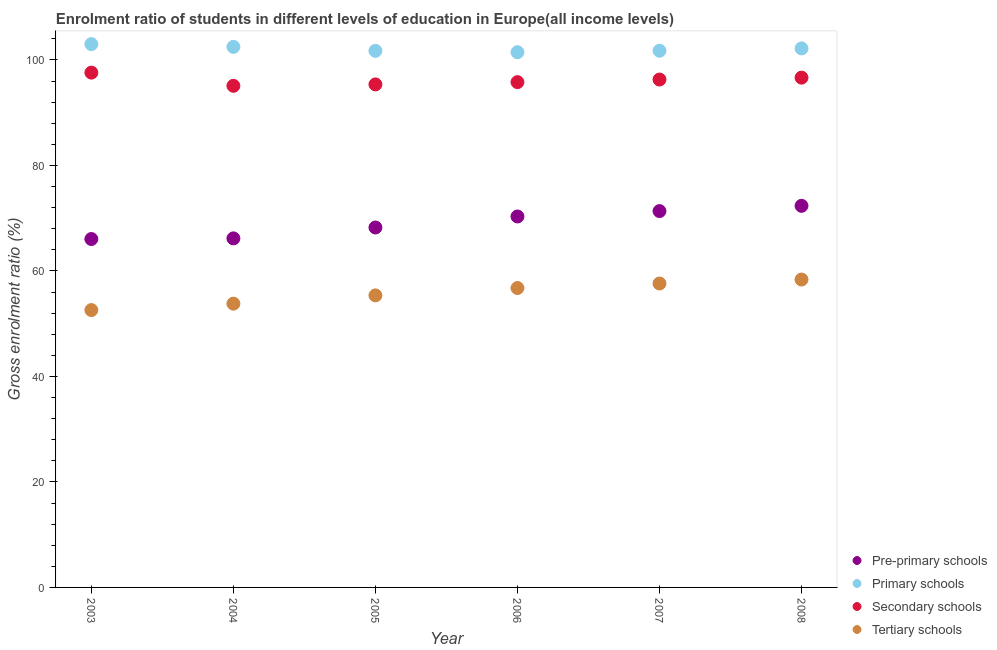What is the gross enrolment ratio in pre-primary schools in 2004?
Offer a very short reply. 66.17. Across all years, what is the maximum gross enrolment ratio in tertiary schools?
Provide a short and direct response. 58.37. Across all years, what is the minimum gross enrolment ratio in tertiary schools?
Ensure brevity in your answer.  52.58. What is the total gross enrolment ratio in tertiary schools in the graph?
Keep it short and to the point. 334.49. What is the difference between the gross enrolment ratio in primary schools in 2005 and that in 2007?
Make the answer very short. -0.02. What is the difference between the gross enrolment ratio in primary schools in 2006 and the gross enrolment ratio in tertiary schools in 2004?
Your response must be concise. 47.67. What is the average gross enrolment ratio in secondary schools per year?
Your response must be concise. 96.13. In the year 2007, what is the difference between the gross enrolment ratio in primary schools and gross enrolment ratio in tertiary schools?
Keep it short and to the point. 44.13. What is the ratio of the gross enrolment ratio in secondary schools in 2003 to that in 2007?
Keep it short and to the point. 1.01. What is the difference between the highest and the second highest gross enrolment ratio in secondary schools?
Keep it short and to the point. 0.95. What is the difference between the highest and the lowest gross enrolment ratio in primary schools?
Your answer should be very brief. 1.53. In how many years, is the gross enrolment ratio in primary schools greater than the average gross enrolment ratio in primary schools taken over all years?
Offer a terse response. 3. Is it the case that in every year, the sum of the gross enrolment ratio in primary schools and gross enrolment ratio in pre-primary schools is greater than the sum of gross enrolment ratio in secondary schools and gross enrolment ratio in tertiary schools?
Ensure brevity in your answer.  No. Is it the case that in every year, the sum of the gross enrolment ratio in pre-primary schools and gross enrolment ratio in primary schools is greater than the gross enrolment ratio in secondary schools?
Keep it short and to the point. Yes. Does the gross enrolment ratio in secondary schools monotonically increase over the years?
Your answer should be very brief. No. Is the gross enrolment ratio in tertiary schools strictly less than the gross enrolment ratio in pre-primary schools over the years?
Make the answer very short. Yes. How many dotlines are there?
Your response must be concise. 4. What is the difference between two consecutive major ticks on the Y-axis?
Offer a terse response. 20. Are the values on the major ticks of Y-axis written in scientific E-notation?
Ensure brevity in your answer.  No. Where does the legend appear in the graph?
Provide a succinct answer. Bottom right. How many legend labels are there?
Your response must be concise. 4. What is the title of the graph?
Keep it short and to the point. Enrolment ratio of students in different levels of education in Europe(all income levels). Does "Periodicity assessment" appear as one of the legend labels in the graph?
Keep it short and to the point. No. What is the label or title of the X-axis?
Offer a very short reply. Year. What is the Gross enrolment ratio (%) in Pre-primary schools in 2003?
Your response must be concise. 66.05. What is the Gross enrolment ratio (%) in Primary schools in 2003?
Provide a succinct answer. 103. What is the Gross enrolment ratio (%) of Secondary schools in 2003?
Offer a terse response. 97.59. What is the Gross enrolment ratio (%) in Tertiary schools in 2003?
Provide a short and direct response. 52.58. What is the Gross enrolment ratio (%) in Pre-primary schools in 2004?
Offer a very short reply. 66.17. What is the Gross enrolment ratio (%) in Primary schools in 2004?
Provide a succinct answer. 102.48. What is the Gross enrolment ratio (%) of Secondary schools in 2004?
Your response must be concise. 95.09. What is the Gross enrolment ratio (%) in Tertiary schools in 2004?
Keep it short and to the point. 53.8. What is the Gross enrolment ratio (%) in Pre-primary schools in 2005?
Make the answer very short. 68.23. What is the Gross enrolment ratio (%) of Primary schools in 2005?
Your answer should be very brief. 101.73. What is the Gross enrolment ratio (%) of Secondary schools in 2005?
Make the answer very short. 95.36. What is the Gross enrolment ratio (%) of Tertiary schools in 2005?
Make the answer very short. 55.37. What is the Gross enrolment ratio (%) of Pre-primary schools in 2006?
Provide a short and direct response. 70.32. What is the Gross enrolment ratio (%) of Primary schools in 2006?
Offer a terse response. 101.46. What is the Gross enrolment ratio (%) of Secondary schools in 2006?
Provide a short and direct response. 95.79. What is the Gross enrolment ratio (%) of Tertiary schools in 2006?
Your response must be concise. 56.76. What is the Gross enrolment ratio (%) in Pre-primary schools in 2007?
Ensure brevity in your answer.  71.35. What is the Gross enrolment ratio (%) in Primary schools in 2007?
Provide a succinct answer. 101.74. What is the Gross enrolment ratio (%) in Secondary schools in 2007?
Offer a terse response. 96.29. What is the Gross enrolment ratio (%) of Tertiary schools in 2007?
Keep it short and to the point. 57.62. What is the Gross enrolment ratio (%) of Pre-primary schools in 2008?
Keep it short and to the point. 72.34. What is the Gross enrolment ratio (%) of Primary schools in 2008?
Keep it short and to the point. 102.19. What is the Gross enrolment ratio (%) of Secondary schools in 2008?
Ensure brevity in your answer.  96.64. What is the Gross enrolment ratio (%) of Tertiary schools in 2008?
Provide a short and direct response. 58.37. Across all years, what is the maximum Gross enrolment ratio (%) in Pre-primary schools?
Offer a very short reply. 72.34. Across all years, what is the maximum Gross enrolment ratio (%) in Primary schools?
Ensure brevity in your answer.  103. Across all years, what is the maximum Gross enrolment ratio (%) of Secondary schools?
Ensure brevity in your answer.  97.59. Across all years, what is the maximum Gross enrolment ratio (%) in Tertiary schools?
Give a very brief answer. 58.37. Across all years, what is the minimum Gross enrolment ratio (%) in Pre-primary schools?
Offer a very short reply. 66.05. Across all years, what is the minimum Gross enrolment ratio (%) in Primary schools?
Your answer should be compact. 101.46. Across all years, what is the minimum Gross enrolment ratio (%) of Secondary schools?
Make the answer very short. 95.09. Across all years, what is the minimum Gross enrolment ratio (%) of Tertiary schools?
Keep it short and to the point. 52.58. What is the total Gross enrolment ratio (%) in Pre-primary schools in the graph?
Your response must be concise. 414.47. What is the total Gross enrolment ratio (%) of Primary schools in the graph?
Offer a terse response. 612.6. What is the total Gross enrolment ratio (%) in Secondary schools in the graph?
Your answer should be very brief. 576.77. What is the total Gross enrolment ratio (%) in Tertiary schools in the graph?
Ensure brevity in your answer.  334.49. What is the difference between the Gross enrolment ratio (%) in Pre-primary schools in 2003 and that in 2004?
Give a very brief answer. -0.12. What is the difference between the Gross enrolment ratio (%) in Primary schools in 2003 and that in 2004?
Give a very brief answer. 0.52. What is the difference between the Gross enrolment ratio (%) in Secondary schools in 2003 and that in 2004?
Offer a very short reply. 2.5. What is the difference between the Gross enrolment ratio (%) of Tertiary schools in 2003 and that in 2004?
Offer a very short reply. -1.21. What is the difference between the Gross enrolment ratio (%) of Pre-primary schools in 2003 and that in 2005?
Give a very brief answer. -2.19. What is the difference between the Gross enrolment ratio (%) in Primary schools in 2003 and that in 2005?
Your answer should be very brief. 1.27. What is the difference between the Gross enrolment ratio (%) of Secondary schools in 2003 and that in 2005?
Ensure brevity in your answer.  2.23. What is the difference between the Gross enrolment ratio (%) of Tertiary schools in 2003 and that in 2005?
Your response must be concise. -2.79. What is the difference between the Gross enrolment ratio (%) of Pre-primary schools in 2003 and that in 2006?
Your response must be concise. -4.28. What is the difference between the Gross enrolment ratio (%) in Primary schools in 2003 and that in 2006?
Give a very brief answer. 1.53. What is the difference between the Gross enrolment ratio (%) of Secondary schools in 2003 and that in 2006?
Keep it short and to the point. 1.8. What is the difference between the Gross enrolment ratio (%) of Tertiary schools in 2003 and that in 2006?
Provide a short and direct response. -4.18. What is the difference between the Gross enrolment ratio (%) in Pre-primary schools in 2003 and that in 2007?
Make the answer very short. -5.3. What is the difference between the Gross enrolment ratio (%) of Primary schools in 2003 and that in 2007?
Keep it short and to the point. 1.25. What is the difference between the Gross enrolment ratio (%) of Secondary schools in 2003 and that in 2007?
Offer a very short reply. 1.31. What is the difference between the Gross enrolment ratio (%) of Tertiary schools in 2003 and that in 2007?
Offer a very short reply. -5.04. What is the difference between the Gross enrolment ratio (%) of Pre-primary schools in 2003 and that in 2008?
Offer a terse response. -6.29. What is the difference between the Gross enrolment ratio (%) of Primary schools in 2003 and that in 2008?
Make the answer very short. 0.81. What is the difference between the Gross enrolment ratio (%) of Secondary schools in 2003 and that in 2008?
Ensure brevity in your answer.  0.95. What is the difference between the Gross enrolment ratio (%) of Tertiary schools in 2003 and that in 2008?
Offer a terse response. -5.79. What is the difference between the Gross enrolment ratio (%) of Pre-primary schools in 2004 and that in 2005?
Offer a very short reply. -2.06. What is the difference between the Gross enrolment ratio (%) in Primary schools in 2004 and that in 2005?
Provide a short and direct response. 0.75. What is the difference between the Gross enrolment ratio (%) in Secondary schools in 2004 and that in 2005?
Your answer should be very brief. -0.27. What is the difference between the Gross enrolment ratio (%) of Tertiary schools in 2004 and that in 2005?
Your response must be concise. -1.57. What is the difference between the Gross enrolment ratio (%) of Pre-primary schools in 2004 and that in 2006?
Provide a short and direct response. -4.15. What is the difference between the Gross enrolment ratio (%) of Primary schools in 2004 and that in 2006?
Make the answer very short. 1.01. What is the difference between the Gross enrolment ratio (%) of Secondary schools in 2004 and that in 2006?
Your answer should be very brief. -0.7. What is the difference between the Gross enrolment ratio (%) of Tertiary schools in 2004 and that in 2006?
Your answer should be compact. -2.97. What is the difference between the Gross enrolment ratio (%) in Pre-primary schools in 2004 and that in 2007?
Your response must be concise. -5.17. What is the difference between the Gross enrolment ratio (%) of Primary schools in 2004 and that in 2007?
Your response must be concise. 0.73. What is the difference between the Gross enrolment ratio (%) in Secondary schools in 2004 and that in 2007?
Give a very brief answer. -1.19. What is the difference between the Gross enrolment ratio (%) in Tertiary schools in 2004 and that in 2007?
Ensure brevity in your answer.  -3.82. What is the difference between the Gross enrolment ratio (%) in Pre-primary schools in 2004 and that in 2008?
Keep it short and to the point. -6.17. What is the difference between the Gross enrolment ratio (%) in Primary schools in 2004 and that in 2008?
Your answer should be very brief. 0.29. What is the difference between the Gross enrolment ratio (%) of Secondary schools in 2004 and that in 2008?
Your response must be concise. -1.55. What is the difference between the Gross enrolment ratio (%) of Tertiary schools in 2004 and that in 2008?
Provide a short and direct response. -4.57. What is the difference between the Gross enrolment ratio (%) of Pre-primary schools in 2005 and that in 2006?
Your response must be concise. -2.09. What is the difference between the Gross enrolment ratio (%) in Primary schools in 2005 and that in 2006?
Your answer should be very brief. 0.26. What is the difference between the Gross enrolment ratio (%) of Secondary schools in 2005 and that in 2006?
Make the answer very short. -0.43. What is the difference between the Gross enrolment ratio (%) in Tertiary schools in 2005 and that in 2006?
Your answer should be compact. -1.4. What is the difference between the Gross enrolment ratio (%) in Pre-primary schools in 2005 and that in 2007?
Keep it short and to the point. -3.11. What is the difference between the Gross enrolment ratio (%) in Primary schools in 2005 and that in 2007?
Your answer should be very brief. -0.02. What is the difference between the Gross enrolment ratio (%) in Secondary schools in 2005 and that in 2007?
Give a very brief answer. -0.92. What is the difference between the Gross enrolment ratio (%) of Tertiary schools in 2005 and that in 2007?
Offer a very short reply. -2.25. What is the difference between the Gross enrolment ratio (%) in Pre-primary schools in 2005 and that in 2008?
Your response must be concise. -4.11. What is the difference between the Gross enrolment ratio (%) of Primary schools in 2005 and that in 2008?
Keep it short and to the point. -0.46. What is the difference between the Gross enrolment ratio (%) in Secondary schools in 2005 and that in 2008?
Offer a very short reply. -1.28. What is the difference between the Gross enrolment ratio (%) of Tertiary schools in 2005 and that in 2008?
Provide a succinct answer. -3. What is the difference between the Gross enrolment ratio (%) of Pre-primary schools in 2006 and that in 2007?
Your response must be concise. -1.02. What is the difference between the Gross enrolment ratio (%) of Primary schools in 2006 and that in 2007?
Your answer should be very brief. -0.28. What is the difference between the Gross enrolment ratio (%) in Secondary schools in 2006 and that in 2007?
Keep it short and to the point. -0.49. What is the difference between the Gross enrolment ratio (%) of Tertiary schools in 2006 and that in 2007?
Give a very brief answer. -0.86. What is the difference between the Gross enrolment ratio (%) of Pre-primary schools in 2006 and that in 2008?
Make the answer very short. -2.02. What is the difference between the Gross enrolment ratio (%) in Primary schools in 2006 and that in 2008?
Ensure brevity in your answer.  -0.73. What is the difference between the Gross enrolment ratio (%) of Secondary schools in 2006 and that in 2008?
Ensure brevity in your answer.  -0.85. What is the difference between the Gross enrolment ratio (%) of Tertiary schools in 2006 and that in 2008?
Offer a terse response. -1.61. What is the difference between the Gross enrolment ratio (%) of Pre-primary schools in 2007 and that in 2008?
Make the answer very short. -1. What is the difference between the Gross enrolment ratio (%) of Primary schools in 2007 and that in 2008?
Keep it short and to the point. -0.45. What is the difference between the Gross enrolment ratio (%) of Secondary schools in 2007 and that in 2008?
Make the answer very short. -0.36. What is the difference between the Gross enrolment ratio (%) of Tertiary schools in 2007 and that in 2008?
Keep it short and to the point. -0.75. What is the difference between the Gross enrolment ratio (%) of Pre-primary schools in 2003 and the Gross enrolment ratio (%) of Primary schools in 2004?
Your answer should be very brief. -36.43. What is the difference between the Gross enrolment ratio (%) in Pre-primary schools in 2003 and the Gross enrolment ratio (%) in Secondary schools in 2004?
Your response must be concise. -29.05. What is the difference between the Gross enrolment ratio (%) of Pre-primary schools in 2003 and the Gross enrolment ratio (%) of Tertiary schools in 2004?
Offer a terse response. 12.25. What is the difference between the Gross enrolment ratio (%) in Primary schools in 2003 and the Gross enrolment ratio (%) in Secondary schools in 2004?
Your response must be concise. 7.9. What is the difference between the Gross enrolment ratio (%) in Primary schools in 2003 and the Gross enrolment ratio (%) in Tertiary schools in 2004?
Give a very brief answer. 49.2. What is the difference between the Gross enrolment ratio (%) of Secondary schools in 2003 and the Gross enrolment ratio (%) of Tertiary schools in 2004?
Keep it short and to the point. 43.8. What is the difference between the Gross enrolment ratio (%) of Pre-primary schools in 2003 and the Gross enrolment ratio (%) of Primary schools in 2005?
Your answer should be very brief. -35.68. What is the difference between the Gross enrolment ratio (%) of Pre-primary schools in 2003 and the Gross enrolment ratio (%) of Secondary schools in 2005?
Your answer should be compact. -29.31. What is the difference between the Gross enrolment ratio (%) of Pre-primary schools in 2003 and the Gross enrolment ratio (%) of Tertiary schools in 2005?
Your response must be concise. 10.68. What is the difference between the Gross enrolment ratio (%) in Primary schools in 2003 and the Gross enrolment ratio (%) in Secondary schools in 2005?
Keep it short and to the point. 7.64. What is the difference between the Gross enrolment ratio (%) of Primary schools in 2003 and the Gross enrolment ratio (%) of Tertiary schools in 2005?
Ensure brevity in your answer.  47.63. What is the difference between the Gross enrolment ratio (%) in Secondary schools in 2003 and the Gross enrolment ratio (%) in Tertiary schools in 2005?
Make the answer very short. 42.23. What is the difference between the Gross enrolment ratio (%) in Pre-primary schools in 2003 and the Gross enrolment ratio (%) in Primary schools in 2006?
Keep it short and to the point. -35.42. What is the difference between the Gross enrolment ratio (%) in Pre-primary schools in 2003 and the Gross enrolment ratio (%) in Secondary schools in 2006?
Your response must be concise. -29.75. What is the difference between the Gross enrolment ratio (%) in Pre-primary schools in 2003 and the Gross enrolment ratio (%) in Tertiary schools in 2006?
Your answer should be very brief. 9.29. What is the difference between the Gross enrolment ratio (%) in Primary schools in 2003 and the Gross enrolment ratio (%) in Secondary schools in 2006?
Make the answer very short. 7.21. What is the difference between the Gross enrolment ratio (%) in Primary schools in 2003 and the Gross enrolment ratio (%) in Tertiary schools in 2006?
Your answer should be compact. 46.24. What is the difference between the Gross enrolment ratio (%) in Secondary schools in 2003 and the Gross enrolment ratio (%) in Tertiary schools in 2006?
Ensure brevity in your answer.  40.83. What is the difference between the Gross enrolment ratio (%) in Pre-primary schools in 2003 and the Gross enrolment ratio (%) in Primary schools in 2007?
Your response must be concise. -35.7. What is the difference between the Gross enrolment ratio (%) of Pre-primary schools in 2003 and the Gross enrolment ratio (%) of Secondary schools in 2007?
Provide a short and direct response. -30.24. What is the difference between the Gross enrolment ratio (%) of Pre-primary schools in 2003 and the Gross enrolment ratio (%) of Tertiary schools in 2007?
Provide a short and direct response. 8.43. What is the difference between the Gross enrolment ratio (%) in Primary schools in 2003 and the Gross enrolment ratio (%) in Secondary schools in 2007?
Give a very brief answer. 6.71. What is the difference between the Gross enrolment ratio (%) of Primary schools in 2003 and the Gross enrolment ratio (%) of Tertiary schools in 2007?
Keep it short and to the point. 45.38. What is the difference between the Gross enrolment ratio (%) in Secondary schools in 2003 and the Gross enrolment ratio (%) in Tertiary schools in 2007?
Your response must be concise. 39.98. What is the difference between the Gross enrolment ratio (%) in Pre-primary schools in 2003 and the Gross enrolment ratio (%) in Primary schools in 2008?
Your answer should be compact. -36.14. What is the difference between the Gross enrolment ratio (%) in Pre-primary schools in 2003 and the Gross enrolment ratio (%) in Secondary schools in 2008?
Your answer should be compact. -30.6. What is the difference between the Gross enrolment ratio (%) in Pre-primary schools in 2003 and the Gross enrolment ratio (%) in Tertiary schools in 2008?
Offer a terse response. 7.68. What is the difference between the Gross enrolment ratio (%) of Primary schools in 2003 and the Gross enrolment ratio (%) of Secondary schools in 2008?
Keep it short and to the point. 6.35. What is the difference between the Gross enrolment ratio (%) in Primary schools in 2003 and the Gross enrolment ratio (%) in Tertiary schools in 2008?
Give a very brief answer. 44.63. What is the difference between the Gross enrolment ratio (%) in Secondary schools in 2003 and the Gross enrolment ratio (%) in Tertiary schools in 2008?
Keep it short and to the point. 39.23. What is the difference between the Gross enrolment ratio (%) of Pre-primary schools in 2004 and the Gross enrolment ratio (%) of Primary schools in 2005?
Keep it short and to the point. -35.55. What is the difference between the Gross enrolment ratio (%) of Pre-primary schools in 2004 and the Gross enrolment ratio (%) of Secondary schools in 2005?
Make the answer very short. -29.19. What is the difference between the Gross enrolment ratio (%) in Pre-primary schools in 2004 and the Gross enrolment ratio (%) in Tertiary schools in 2005?
Make the answer very short. 10.81. What is the difference between the Gross enrolment ratio (%) in Primary schools in 2004 and the Gross enrolment ratio (%) in Secondary schools in 2005?
Ensure brevity in your answer.  7.11. What is the difference between the Gross enrolment ratio (%) in Primary schools in 2004 and the Gross enrolment ratio (%) in Tertiary schools in 2005?
Keep it short and to the point. 47.11. What is the difference between the Gross enrolment ratio (%) of Secondary schools in 2004 and the Gross enrolment ratio (%) of Tertiary schools in 2005?
Your answer should be very brief. 39.73. What is the difference between the Gross enrolment ratio (%) of Pre-primary schools in 2004 and the Gross enrolment ratio (%) of Primary schools in 2006?
Offer a very short reply. -35.29. What is the difference between the Gross enrolment ratio (%) of Pre-primary schools in 2004 and the Gross enrolment ratio (%) of Secondary schools in 2006?
Your answer should be compact. -29.62. What is the difference between the Gross enrolment ratio (%) in Pre-primary schools in 2004 and the Gross enrolment ratio (%) in Tertiary schools in 2006?
Provide a succinct answer. 9.41. What is the difference between the Gross enrolment ratio (%) in Primary schools in 2004 and the Gross enrolment ratio (%) in Secondary schools in 2006?
Offer a terse response. 6.68. What is the difference between the Gross enrolment ratio (%) in Primary schools in 2004 and the Gross enrolment ratio (%) in Tertiary schools in 2006?
Your response must be concise. 45.72. What is the difference between the Gross enrolment ratio (%) in Secondary schools in 2004 and the Gross enrolment ratio (%) in Tertiary schools in 2006?
Offer a very short reply. 38.33. What is the difference between the Gross enrolment ratio (%) of Pre-primary schools in 2004 and the Gross enrolment ratio (%) of Primary schools in 2007?
Offer a very short reply. -35.57. What is the difference between the Gross enrolment ratio (%) of Pre-primary schools in 2004 and the Gross enrolment ratio (%) of Secondary schools in 2007?
Keep it short and to the point. -30.11. What is the difference between the Gross enrolment ratio (%) of Pre-primary schools in 2004 and the Gross enrolment ratio (%) of Tertiary schools in 2007?
Provide a succinct answer. 8.56. What is the difference between the Gross enrolment ratio (%) of Primary schools in 2004 and the Gross enrolment ratio (%) of Secondary schools in 2007?
Your response must be concise. 6.19. What is the difference between the Gross enrolment ratio (%) of Primary schools in 2004 and the Gross enrolment ratio (%) of Tertiary schools in 2007?
Make the answer very short. 44.86. What is the difference between the Gross enrolment ratio (%) in Secondary schools in 2004 and the Gross enrolment ratio (%) in Tertiary schools in 2007?
Your answer should be very brief. 37.48. What is the difference between the Gross enrolment ratio (%) of Pre-primary schools in 2004 and the Gross enrolment ratio (%) of Primary schools in 2008?
Provide a succinct answer. -36.02. What is the difference between the Gross enrolment ratio (%) of Pre-primary schools in 2004 and the Gross enrolment ratio (%) of Secondary schools in 2008?
Provide a succinct answer. -30.47. What is the difference between the Gross enrolment ratio (%) of Pre-primary schools in 2004 and the Gross enrolment ratio (%) of Tertiary schools in 2008?
Keep it short and to the point. 7.8. What is the difference between the Gross enrolment ratio (%) of Primary schools in 2004 and the Gross enrolment ratio (%) of Secondary schools in 2008?
Your response must be concise. 5.83. What is the difference between the Gross enrolment ratio (%) in Primary schools in 2004 and the Gross enrolment ratio (%) in Tertiary schools in 2008?
Offer a very short reply. 44.11. What is the difference between the Gross enrolment ratio (%) in Secondary schools in 2004 and the Gross enrolment ratio (%) in Tertiary schools in 2008?
Your response must be concise. 36.72. What is the difference between the Gross enrolment ratio (%) of Pre-primary schools in 2005 and the Gross enrolment ratio (%) of Primary schools in 2006?
Your answer should be compact. -33.23. What is the difference between the Gross enrolment ratio (%) of Pre-primary schools in 2005 and the Gross enrolment ratio (%) of Secondary schools in 2006?
Your answer should be very brief. -27.56. What is the difference between the Gross enrolment ratio (%) in Pre-primary schools in 2005 and the Gross enrolment ratio (%) in Tertiary schools in 2006?
Provide a succinct answer. 11.47. What is the difference between the Gross enrolment ratio (%) of Primary schools in 2005 and the Gross enrolment ratio (%) of Secondary schools in 2006?
Provide a short and direct response. 5.93. What is the difference between the Gross enrolment ratio (%) of Primary schools in 2005 and the Gross enrolment ratio (%) of Tertiary schools in 2006?
Offer a very short reply. 44.97. What is the difference between the Gross enrolment ratio (%) in Secondary schools in 2005 and the Gross enrolment ratio (%) in Tertiary schools in 2006?
Provide a short and direct response. 38.6. What is the difference between the Gross enrolment ratio (%) in Pre-primary schools in 2005 and the Gross enrolment ratio (%) in Primary schools in 2007?
Offer a terse response. -33.51. What is the difference between the Gross enrolment ratio (%) in Pre-primary schools in 2005 and the Gross enrolment ratio (%) in Secondary schools in 2007?
Offer a very short reply. -28.05. What is the difference between the Gross enrolment ratio (%) of Pre-primary schools in 2005 and the Gross enrolment ratio (%) of Tertiary schools in 2007?
Keep it short and to the point. 10.62. What is the difference between the Gross enrolment ratio (%) in Primary schools in 2005 and the Gross enrolment ratio (%) in Secondary schools in 2007?
Offer a terse response. 5.44. What is the difference between the Gross enrolment ratio (%) of Primary schools in 2005 and the Gross enrolment ratio (%) of Tertiary schools in 2007?
Your response must be concise. 44.11. What is the difference between the Gross enrolment ratio (%) of Secondary schools in 2005 and the Gross enrolment ratio (%) of Tertiary schools in 2007?
Provide a short and direct response. 37.75. What is the difference between the Gross enrolment ratio (%) in Pre-primary schools in 2005 and the Gross enrolment ratio (%) in Primary schools in 2008?
Your response must be concise. -33.96. What is the difference between the Gross enrolment ratio (%) in Pre-primary schools in 2005 and the Gross enrolment ratio (%) in Secondary schools in 2008?
Your answer should be compact. -28.41. What is the difference between the Gross enrolment ratio (%) in Pre-primary schools in 2005 and the Gross enrolment ratio (%) in Tertiary schools in 2008?
Provide a short and direct response. 9.87. What is the difference between the Gross enrolment ratio (%) in Primary schools in 2005 and the Gross enrolment ratio (%) in Secondary schools in 2008?
Ensure brevity in your answer.  5.08. What is the difference between the Gross enrolment ratio (%) in Primary schools in 2005 and the Gross enrolment ratio (%) in Tertiary schools in 2008?
Ensure brevity in your answer.  43.36. What is the difference between the Gross enrolment ratio (%) in Secondary schools in 2005 and the Gross enrolment ratio (%) in Tertiary schools in 2008?
Offer a terse response. 36.99. What is the difference between the Gross enrolment ratio (%) in Pre-primary schools in 2006 and the Gross enrolment ratio (%) in Primary schools in 2007?
Ensure brevity in your answer.  -31.42. What is the difference between the Gross enrolment ratio (%) in Pre-primary schools in 2006 and the Gross enrolment ratio (%) in Secondary schools in 2007?
Your answer should be very brief. -25.96. What is the difference between the Gross enrolment ratio (%) in Pre-primary schools in 2006 and the Gross enrolment ratio (%) in Tertiary schools in 2007?
Offer a terse response. 12.71. What is the difference between the Gross enrolment ratio (%) of Primary schools in 2006 and the Gross enrolment ratio (%) of Secondary schools in 2007?
Keep it short and to the point. 5.18. What is the difference between the Gross enrolment ratio (%) in Primary schools in 2006 and the Gross enrolment ratio (%) in Tertiary schools in 2007?
Provide a succinct answer. 43.85. What is the difference between the Gross enrolment ratio (%) in Secondary schools in 2006 and the Gross enrolment ratio (%) in Tertiary schools in 2007?
Offer a very short reply. 38.18. What is the difference between the Gross enrolment ratio (%) of Pre-primary schools in 2006 and the Gross enrolment ratio (%) of Primary schools in 2008?
Your response must be concise. -31.87. What is the difference between the Gross enrolment ratio (%) of Pre-primary schools in 2006 and the Gross enrolment ratio (%) of Secondary schools in 2008?
Your response must be concise. -26.32. What is the difference between the Gross enrolment ratio (%) of Pre-primary schools in 2006 and the Gross enrolment ratio (%) of Tertiary schools in 2008?
Ensure brevity in your answer.  11.96. What is the difference between the Gross enrolment ratio (%) in Primary schools in 2006 and the Gross enrolment ratio (%) in Secondary schools in 2008?
Give a very brief answer. 4.82. What is the difference between the Gross enrolment ratio (%) in Primary schools in 2006 and the Gross enrolment ratio (%) in Tertiary schools in 2008?
Your response must be concise. 43.1. What is the difference between the Gross enrolment ratio (%) of Secondary schools in 2006 and the Gross enrolment ratio (%) of Tertiary schools in 2008?
Give a very brief answer. 37.42. What is the difference between the Gross enrolment ratio (%) in Pre-primary schools in 2007 and the Gross enrolment ratio (%) in Primary schools in 2008?
Ensure brevity in your answer.  -30.84. What is the difference between the Gross enrolment ratio (%) in Pre-primary schools in 2007 and the Gross enrolment ratio (%) in Secondary schools in 2008?
Offer a terse response. -25.3. What is the difference between the Gross enrolment ratio (%) of Pre-primary schools in 2007 and the Gross enrolment ratio (%) of Tertiary schools in 2008?
Ensure brevity in your answer.  12.98. What is the difference between the Gross enrolment ratio (%) in Primary schools in 2007 and the Gross enrolment ratio (%) in Secondary schools in 2008?
Your answer should be very brief. 5.1. What is the difference between the Gross enrolment ratio (%) of Primary schools in 2007 and the Gross enrolment ratio (%) of Tertiary schools in 2008?
Provide a short and direct response. 43.37. What is the difference between the Gross enrolment ratio (%) in Secondary schools in 2007 and the Gross enrolment ratio (%) in Tertiary schools in 2008?
Ensure brevity in your answer.  37.92. What is the average Gross enrolment ratio (%) of Pre-primary schools per year?
Your response must be concise. 69.08. What is the average Gross enrolment ratio (%) of Primary schools per year?
Offer a very short reply. 102.1. What is the average Gross enrolment ratio (%) in Secondary schools per year?
Your answer should be compact. 96.13. What is the average Gross enrolment ratio (%) in Tertiary schools per year?
Your response must be concise. 55.75. In the year 2003, what is the difference between the Gross enrolment ratio (%) in Pre-primary schools and Gross enrolment ratio (%) in Primary schools?
Provide a short and direct response. -36.95. In the year 2003, what is the difference between the Gross enrolment ratio (%) of Pre-primary schools and Gross enrolment ratio (%) of Secondary schools?
Your answer should be very brief. -31.55. In the year 2003, what is the difference between the Gross enrolment ratio (%) in Pre-primary schools and Gross enrolment ratio (%) in Tertiary schools?
Provide a short and direct response. 13.47. In the year 2003, what is the difference between the Gross enrolment ratio (%) in Primary schools and Gross enrolment ratio (%) in Secondary schools?
Offer a terse response. 5.4. In the year 2003, what is the difference between the Gross enrolment ratio (%) in Primary schools and Gross enrolment ratio (%) in Tertiary schools?
Ensure brevity in your answer.  50.42. In the year 2003, what is the difference between the Gross enrolment ratio (%) of Secondary schools and Gross enrolment ratio (%) of Tertiary schools?
Provide a succinct answer. 45.01. In the year 2004, what is the difference between the Gross enrolment ratio (%) in Pre-primary schools and Gross enrolment ratio (%) in Primary schools?
Your response must be concise. -36.3. In the year 2004, what is the difference between the Gross enrolment ratio (%) in Pre-primary schools and Gross enrolment ratio (%) in Secondary schools?
Your response must be concise. -28.92. In the year 2004, what is the difference between the Gross enrolment ratio (%) in Pre-primary schools and Gross enrolment ratio (%) in Tertiary schools?
Provide a succinct answer. 12.38. In the year 2004, what is the difference between the Gross enrolment ratio (%) in Primary schools and Gross enrolment ratio (%) in Secondary schools?
Offer a terse response. 7.38. In the year 2004, what is the difference between the Gross enrolment ratio (%) of Primary schools and Gross enrolment ratio (%) of Tertiary schools?
Make the answer very short. 48.68. In the year 2004, what is the difference between the Gross enrolment ratio (%) of Secondary schools and Gross enrolment ratio (%) of Tertiary schools?
Provide a succinct answer. 41.3. In the year 2005, what is the difference between the Gross enrolment ratio (%) in Pre-primary schools and Gross enrolment ratio (%) in Primary schools?
Offer a very short reply. -33.49. In the year 2005, what is the difference between the Gross enrolment ratio (%) of Pre-primary schools and Gross enrolment ratio (%) of Secondary schools?
Provide a short and direct response. -27.13. In the year 2005, what is the difference between the Gross enrolment ratio (%) in Pre-primary schools and Gross enrolment ratio (%) in Tertiary schools?
Provide a short and direct response. 12.87. In the year 2005, what is the difference between the Gross enrolment ratio (%) in Primary schools and Gross enrolment ratio (%) in Secondary schools?
Your response must be concise. 6.36. In the year 2005, what is the difference between the Gross enrolment ratio (%) of Primary schools and Gross enrolment ratio (%) of Tertiary schools?
Keep it short and to the point. 46.36. In the year 2005, what is the difference between the Gross enrolment ratio (%) of Secondary schools and Gross enrolment ratio (%) of Tertiary schools?
Ensure brevity in your answer.  40. In the year 2006, what is the difference between the Gross enrolment ratio (%) of Pre-primary schools and Gross enrolment ratio (%) of Primary schools?
Make the answer very short. -31.14. In the year 2006, what is the difference between the Gross enrolment ratio (%) of Pre-primary schools and Gross enrolment ratio (%) of Secondary schools?
Ensure brevity in your answer.  -25.47. In the year 2006, what is the difference between the Gross enrolment ratio (%) of Pre-primary schools and Gross enrolment ratio (%) of Tertiary schools?
Your answer should be very brief. 13.56. In the year 2006, what is the difference between the Gross enrolment ratio (%) of Primary schools and Gross enrolment ratio (%) of Secondary schools?
Give a very brief answer. 5.67. In the year 2006, what is the difference between the Gross enrolment ratio (%) of Primary schools and Gross enrolment ratio (%) of Tertiary schools?
Ensure brevity in your answer.  44.7. In the year 2006, what is the difference between the Gross enrolment ratio (%) in Secondary schools and Gross enrolment ratio (%) in Tertiary schools?
Your response must be concise. 39.03. In the year 2007, what is the difference between the Gross enrolment ratio (%) of Pre-primary schools and Gross enrolment ratio (%) of Primary schools?
Your response must be concise. -30.4. In the year 2007, what is the difference between the Gross enrolment ratio (%) in Pre-primary schools and Gross enrolment ratio (%) in Secondary schools?
Ensure brevity in your answer.  -24.94. In the year 2007, what is the difference between the Gross enrolment ratio (%) of Pre-primary schools and Gross enrolment ratio (%) of Tertiary schools?
Provide a short and direct response. 13.73. In the year 2007, what is the difference between the Gross enrolment ratio (%) of Primary schools and Gross enrolment ratio (%) of Secondary schools?
Your answer should be compact. 5.46. In the year 2007, what is the difference between the Gross enrolment ratio (%) in Primary schools and Gross enrolment ratio (%) in Tertiary schools?
Offer a terse response. 44.13. In the year 2007, what is the difference between the Gross enrolment ratio (%) of Secondary schools and Gross enrolment ratio (%) of Tertiary schools?
Give a very brief answer. 38.67. In the year 2008, what is the difference between the Gross enrolment ratio (%) in Pre-primary schools and Gross enrolment ratio (%) in Primary schools?
Ensure brevity in your answer.  -29.85. In the year 2008, what is the difference between the Gross enrolment ratio (%) of Pre-primary schools and Gross enrolment ratio (%) of Secondary schools?
Make the answer very short. -24.3. In the year 2008, what is the difference between the Gross enrolment ratio (%) of Pre-primary schools and Gross enrolment ratio (%) of Tertiary schools?
Make the answer very short. 13.97. In the year 2008, what is the difference between the Gross enrolment ratio (%) of Primary schools and Gross enrolment ratio (%) of Secondary schools?
Provide a succinct answer. 5.55. In the year 2008, what is the difference between the Gross enrolment ratio (%) in Primary schools and Gross enrolment ratio (%) in Tertiary schools?
Keep it short and to the point. 43.82. In the year 2008, what is the difference between the Gross enrolment ratio (%) of Secondary schools and Gross enrolment ratio (%) of Tertiary schools?
Provide a short and direct response. 38.27. What is the ratio of the Gross enrolment ratio (%) of Pre-primary schools in 2003 to that in 2004?
Your response must be concise. 1. What is the ratio of the Gross enrolment ratio (%) of Primary schools in 2003 to that in 2004?
Ensure brevity in your answer.  1.01. What is the ratio of the Gross enrolment ratio (%) in Secondary schools in 2003 to that in 2004?
Your response must be concise. 1.03. What is the ratio of the Gross enrolment ratio (%) in Tertiary schools in 2003 to that in 2004?
Your answer should be very brief. 0.98. What is the ratio of the Gross enrolment ratio (%) in Primary schools in 2003 to that in 2005?
Give a very brief answer. 1.01. What is the ratio of the Gross enrolment ratio (%) in Secondary schools in 2003 to that in 2005?
Make the answer very short. 1.02. What is the ratio of the Gross enrolment ratio (%) of Tertiary schools in 2003 to that in 2005?
Your response must be concise. 0.95. What is the ratio of the Gross enrolment ratio (%) in Pre-primary schools in 2003 to that in 2006?
Your answer should be very brief. 0.94. What is the ratio of the Gross enrolment ratio (%) in Primary schools in 2003 to that in 2006?
Your answer should be very brief. 1.02. What is the ratio of the Gross enrolment ratio (%) of Secondary schools in 2003 to that in 2006?
Provide a short and direct response. 1.02. What is the ratio of the Gross enrolment ratio (%) in Tertiary schools in 2003 to that in 2006?
Give a very brief answer. 0.93. What is the ratio of the Gross enrolment ratio (%) of Pre-primary schools in 2003 to that in 2007?
Provide a short and direct response. 0.93. What is the ratio of the Gross enrolment ratio (%) of Primary schools in 2003 to that in 2007?
Provide a succinct answer. 1.01. What is the ratio of the Gross enrolment ratio (%) in Secondary schools in 2003 to that in 2007?
Your response must be concise. 1.01. What is the ratio of the Gross enrolment ratio (%) in Tertiary schools in 2003 to that in 2007?
Give a very brief answer. 0.91. What is the ratio of the Gross enrolment ratio (%) of Pre-primary schools in 2003 to that in 2008?
Provide a short and direct response. 0.91. What is the ratio of the Gross enrolment ratio (%) of Primary schools in 2003 to that in 2008?
Your answer should be very brief. 1.01. What is the ratio of the Gross enrolment ratio (%) in Secondary schools in 2003 to that in 2008?
Ensure brevity in your answer.  1.01. What is the ratio of the Gross enrolment ratio (%) of Tertiary schools in 2003 to that in 2008?
Offer a terse response. 0.9. What is the ratio of the Gross enrolment ratio (%) in Pre-primary schools in 2004 to that in 2005?
Provide a succinct answer. 0.97. What is the ratio of the Gross enrolment ratio (%) of Primary schools in 2004 to that in 2005?
Your answer should be compact. 1.01. What is the ratio of the Gross enrolment ratio (%) of Secondary schools in 2004 to that in 2005?
Offer a very short reply. 1. What is the ratio of the Gross enrolment ratio (%) in Tertiary schools in 2004 to that in 2005?
Your answer should be compact. 0.97. What is the ratio of the Gross enrolment ratio (%) in Pre-primary schools in 2004 to that in 2006?
Offer a very short reply. 0.94. What is the ratio of the Gross enrolment ratio (%) in Tertiary schools in 2004 to that in 2006?
Keep it short and to the point. 0.95. What is the ratio of the Gross enrolment ratio (%) in Pre-primary schools in 2004 to that in 2007?
Your response must be concise. 0.93. What is the ratio of the Gross enrolment ratio (%) in Primary schools in 2004 to that in 2007?
Your response must be concise. 1.01. What is the ratio of the Gross enrolment ratio (%) in Secondary schools in 2004 to that in 2007?
Offer a terse response. 0.99. What is the ratio of the Gross enrolment ratio (%) in Tertiary schools in 2004 to that in 2007?
Your answer should be very brief. 0.93. What is the ratio of the Gross enrolment ratio (%) in Pre-primary schools in 2004 to that in 2008?
Offer a terse response. 0.91. What is the ratio of the Gross enrolment ratio (%) in Tertiary schools in 2004 to that in 2008?
Keep it short and to the point. 0.92. What is the ratio of the Gross enrolment ratio (%) of Pre-primary schools in 2005 to that in 2006?
Offer a terse response. 0.97. What is the ratio of the Gross enrolment ratio (%) of Primary schools in 2005 to that in 2006?
Make the answer very short. 1. What is the ratio of the Gross enrolment ratio (%) of Tertiary schools in 2005 to that in 2006?
Keep it short and to the point. 0.98. What is the ratio of the Gross enrolment ratio (%) in Pre-primary schools in 2005 to that in 2007?
Give a very brief answer. 0.96. What is the ratio of the Gross enrolment ratio (%) in Primary schools in 2005 to that in 2007?
Your response must be concise. 1. What is the ratio of the Gross enrolment ratio (%) in Secondary schools in 2005 to that in 2007?
Make the answer very short. 0.99. What is the ratio of the Gross enrolment ratio (%) in Tertiary schools in 2005 to that in 2007?
Ensure brevity in your answer.  0.96. What is the ratio of the Gross enrolment ratio (%) in Pre-primary schools in 2005 to that in 2008?
Your answer should be compact. 0.94. What is the ratio of the Gross enrolment ratio (%) of Secondary schools in 2005 to that in 2008?
Provide a succinct answer. 0.99. What is the ratio of the Gross enrolment ratio (%) of Tertiary schools in 2005 to that in 2008?
Make the answer very short. 0.95. What is the ratio of the Gross enrolment ratio (%) of Pre-primary schools in 2006 to that in 2007?
Give a very brief answer. 0.99. What is the ratio of the Gross enrolment ratio (%) in Tertiary schools in 2006 to that in 2007?
Keep it short and to the point. 0.99. What is the ratio of the Gross enrolment ratio (%) of Pre-primary schools in 2006 to that in 2008?
Provide a short and direct response. 0.97. What is the ratio of the Gross enrolment ratio (%) in Primary schools in 2006 to that in 2008?
Provide a succinct answer. 0.99. What is the ratio of the Gross enrolment ratio (%) in Tertiary schools in 2006 to that in 2008?
Make the answer very short. 0.97. What is the ratio of the Gross enrolment ratio (%) of Pre-primary schools in 2007 to that in 2008?
Your response must be concise. 0.99. What is the ratio of the Gross enrolment ratio (%) in Secondary schools in 2007 to that in 2008?
Your response must be concise. 1. What is the ratio of the Gross enrolment ratio (%) of Tertiary schools in 2007 to that in 2008?
Offer a terse response. 0.99. What is the difference between the highest and the second highest Gross enrolment ratio (%) of Pre-primary schools?
Your response must be concise. 1. What is the difference between the highest and the second highest Gross enrolment ratio (%) in Primary schools?
Give a very brief answer. 0.52. What is the difference between the highest and the second highest Gross enrolment ratio (%) of Secondary schools?
Your answer should be very brief. 0.95. What is the difference between the highest and the second highest Gross enrolment ratio (%) of Tertiary schools?
Your answer should be compact. 0.75. What is the difference between the highest and the lowest Gross enrolment ratio (%) of Pre-primary schools?
Make the answer very short. 6.29. What is the difference between the highest and the lowest Gross enrolment ratio (%) of Primary schools?
Your response must be concise. 1.53. What is the difference between the highest and the lowest Gross enrolment ratio (%) in Secondary schools?
Your response must be concise. 2.5. What is the difference between the highest and the lowest Gross enrolment ratio (%) in Tertiary schools?
Your response must be concise. 5.79. 